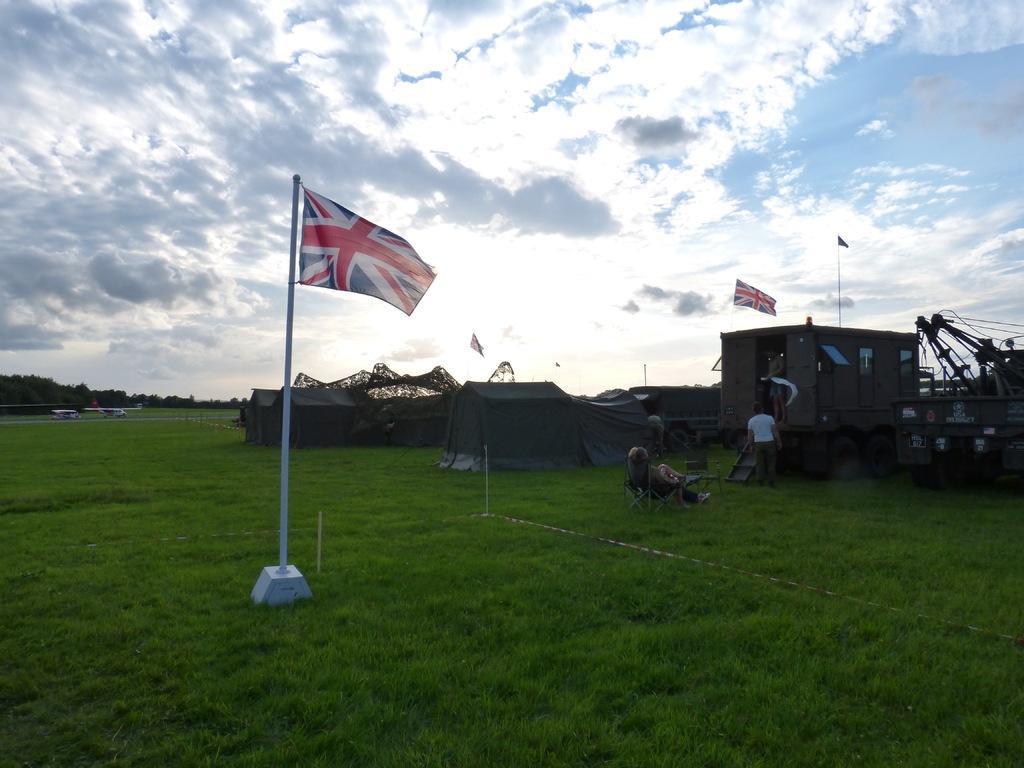In one or two sentences, can you explain what this image depicts? This image is clicked outside. There is a flag in the middle and right side. There is sky at the top. There is grass at the bottom. There is a building on the right side. 